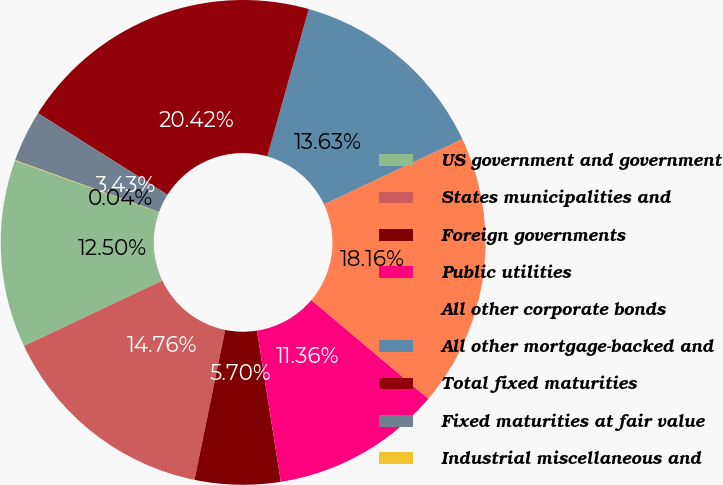Convert chart. <chart><loc_0><loc_0><loc_500><loc_500><pie_chart><fcel>US government and government<fcel>States municipalities and<fcel>Foreign governments<fcel>Public utilities<fcel>All other corporate bonds<fcel>All other mortgage-backed and<fcel>Total fixed maturities<fcel>Fixed maturities at fair value<fcel>Industrial miscellaneous and<nl><fcel>12.5%<fcel>14.76%<fcel>5.7%<fcel>11.36%<fcel>18.16%<fcel>13.63%<fcel>20.42%<fcel>3.43%<fcel>0.04%<nl></chart> 